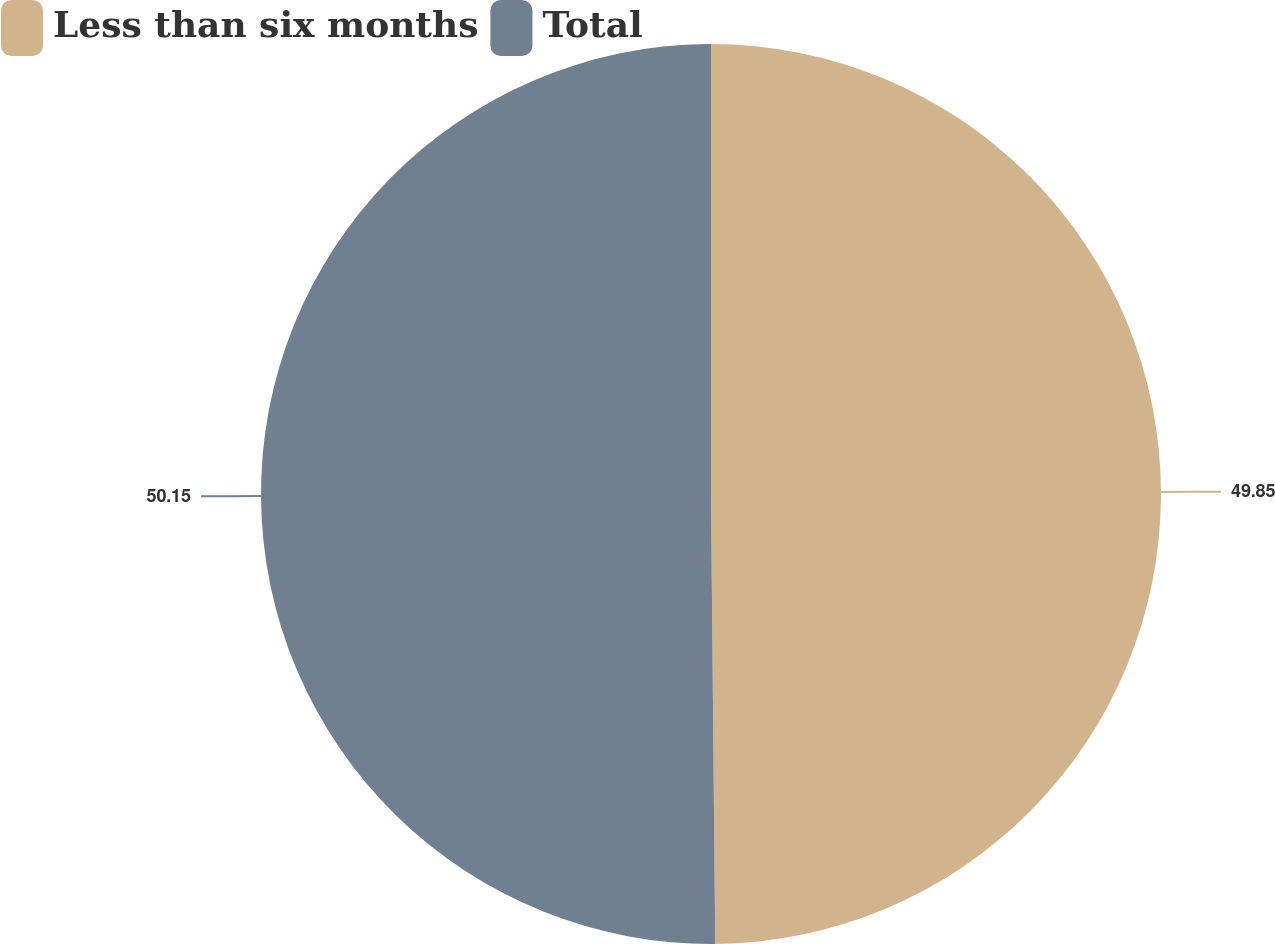Convert chart. <chart><loc_0><loc_0><loc_500><loc_500><pie_chart><fcel>Less than six months<fcel>Total<nl><fcel>49.85%<fcel>50.15%<nl></chart> 